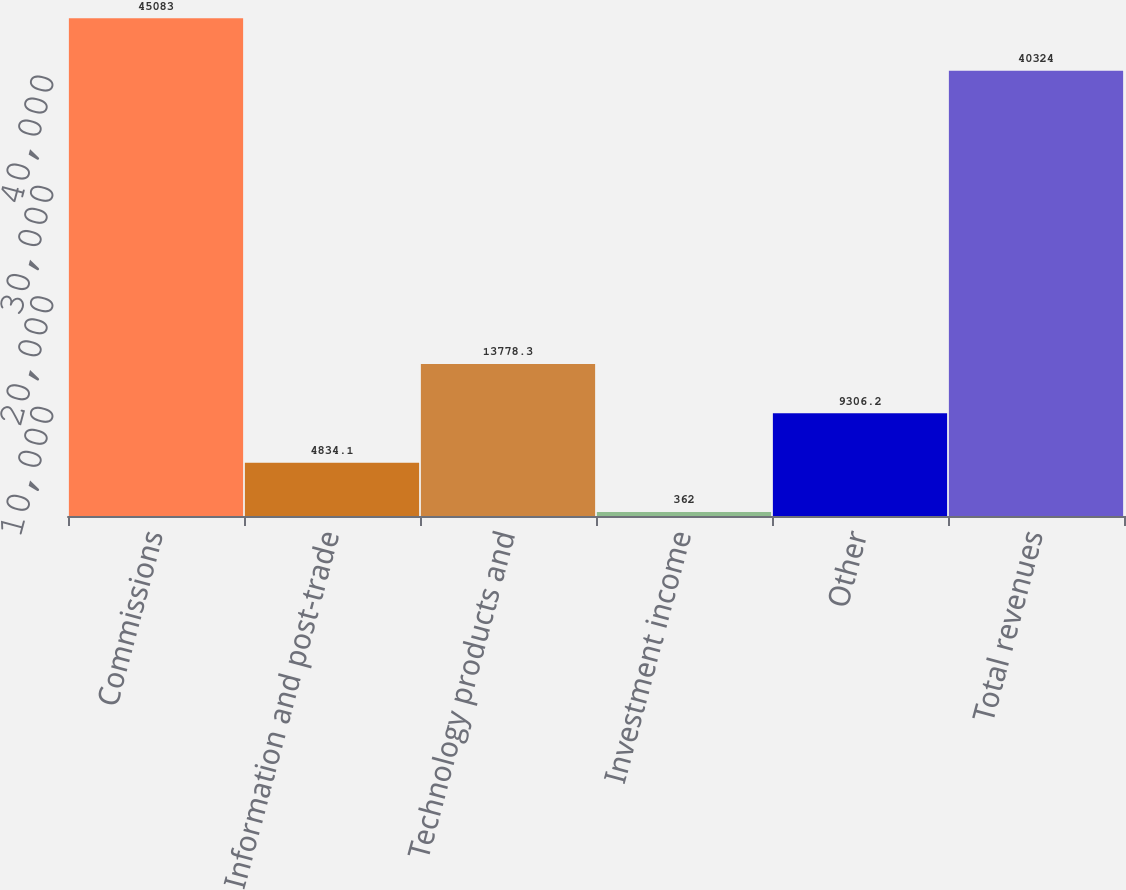Convert chart to OTSL. <chart><loc_0><loc_0><loc_500><loc_500><bar_chart><fcel>Commissions<fcel>Information and post-trade<fcel>Technology products and<fcel>Investment income<fcel>Other<fcel>Total revenues<nl><fcel>45083<fcel>4834.1<fcel>13778.3<fcel>362<fcel>9306.2<fcel>40324<nl></chart> 